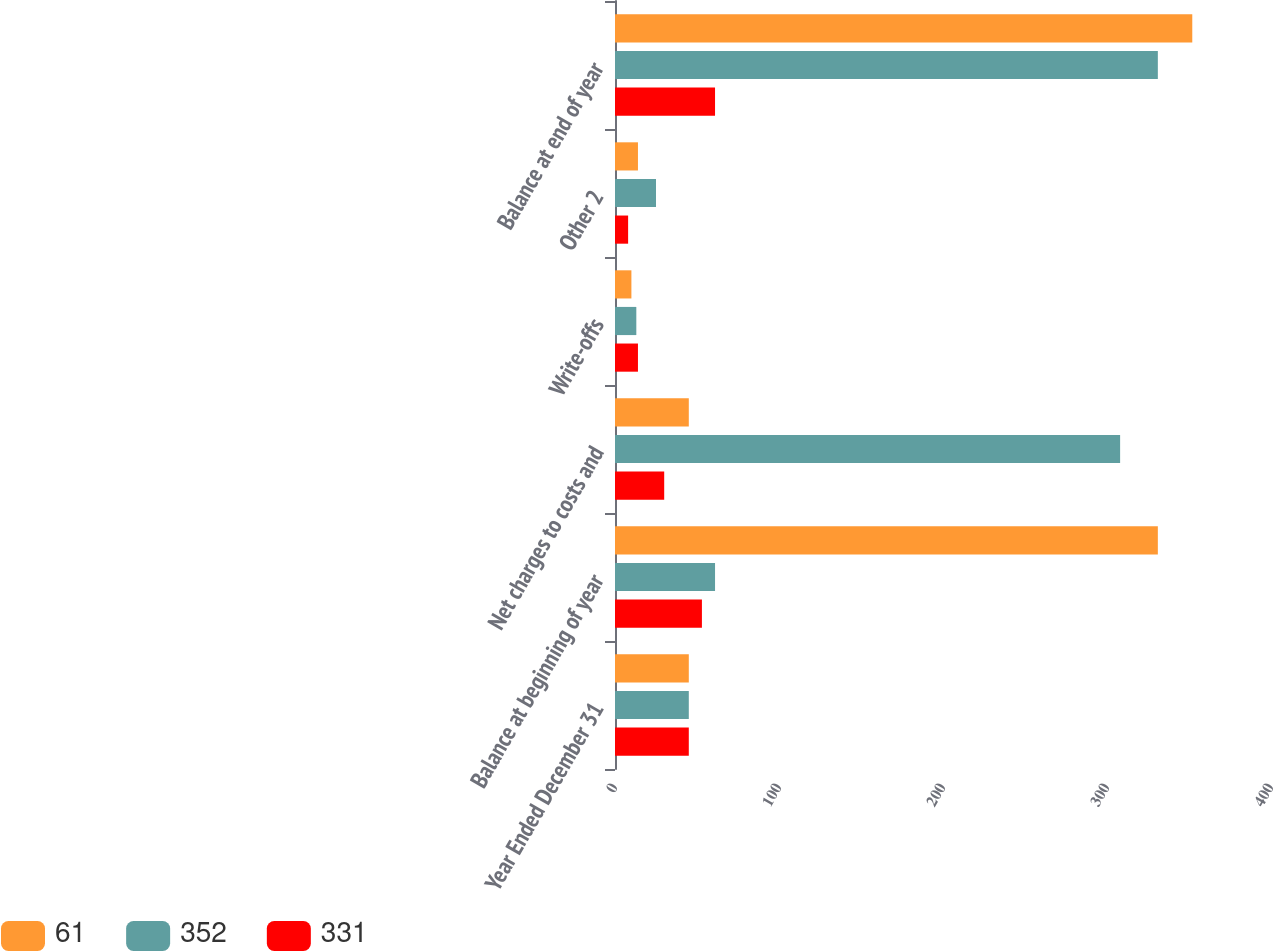Convert chart to OTSL. <chart><loc_0><loc_0><loc_500><loc_500><stacked_bar_chart><ecel><fcel>Year Ended December 31<fcel>Balance at beginning of year<fcel>Net charges to costs and<fcel>Write-offs<fcel>Other 2<fcel>Balance at end of year<nl><fcel>61<fcel>45<fcel>331<fcel>45<fcel>10<fcel>14<fcel>352<nl><fcel>352<fcel>45<fcel>61<fcel>308<fcel>13<fcel>25<fcel>331<nl><fcel>331<fcel>45<fcel>53<fcel>30<fcel>14<fcel>8<fcel>61<nl></chart> 